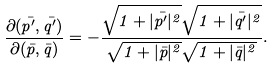<formula> <loc_0><loc_0><loc_500><loc_500>\frac { \partial ( \bar { p ^ { \prime } } , \bar { q ^ { \prime } } ) } { \partial ( \bar { p } , \bar { q } ) } = - \frac { \sqrt { 1 + | \bar { p ^ { \prime } } | ^ { 2 } } \sqrt { 1 + | \bar { q ^ { \prime } } | ^ { 2 } } } { \sqrt { 1 + | \bar { p } | ^ { 2 } } \sqrt { 1 + | \bar { q } | ^ { 2 } } } .</formula> 